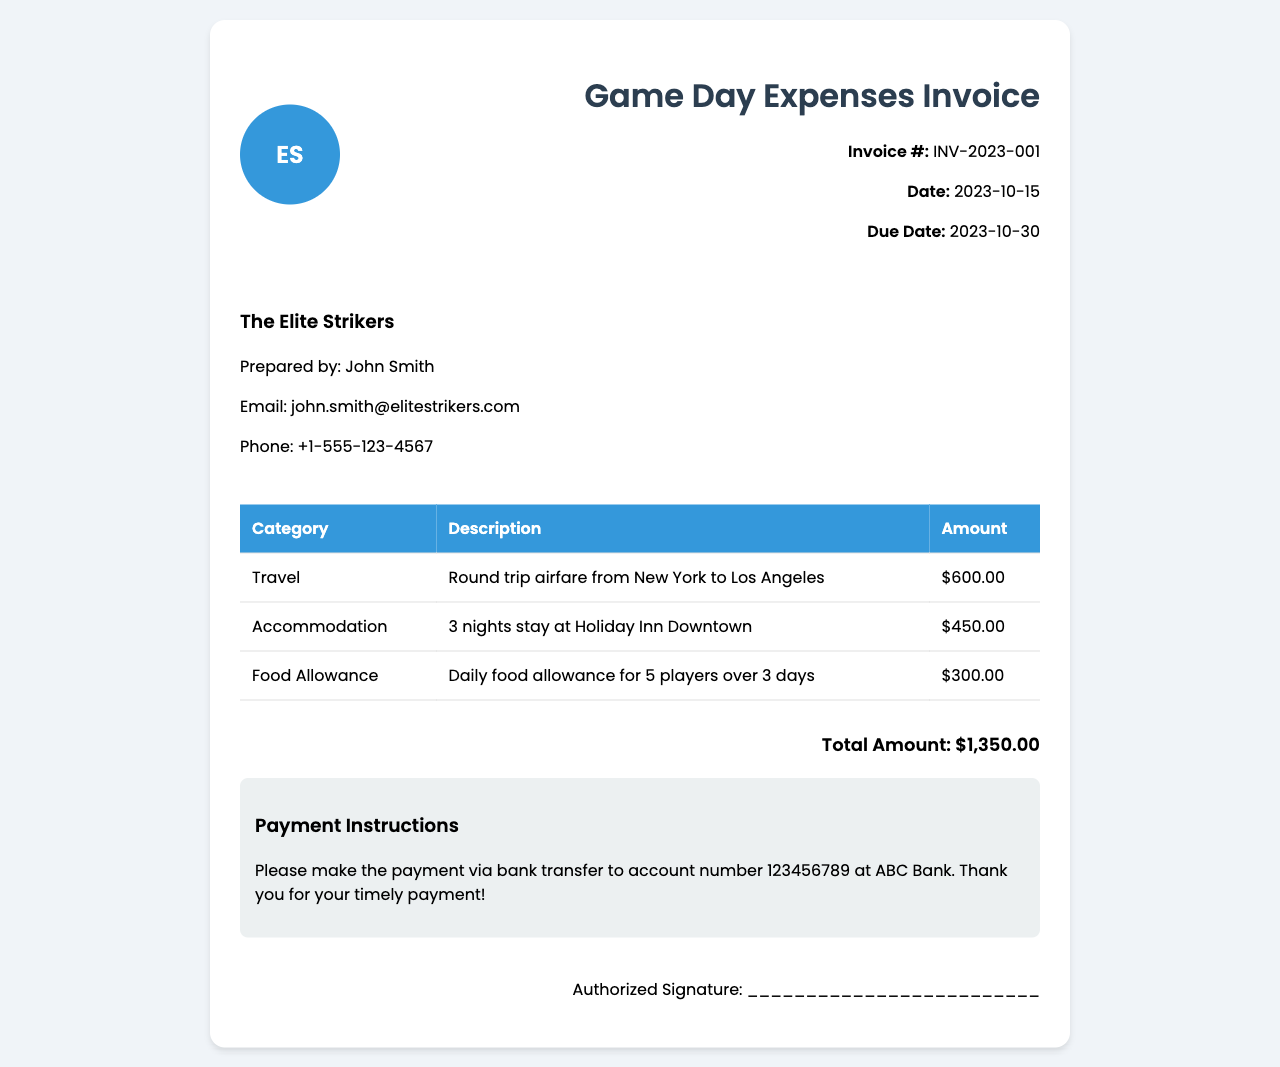What is the invoice number? The invoice number is listed in the document as a unique identifier for the invoice.
Answer: INV-2023-001 What is the date of the invoice? The date indicates when the invoice was issued, which is provided in the document.
Answer: 2023-10-15 How much was spent on accommodation? The accommodation cost is a specific line item in the invoice detailing the expenses.
Answer: $450.00 Who prepared the invoice? The preparer's name is mentioned to indicate responsibility for the document.
Answer: John Smith How many nights was the team accommodated? The number of nights is specified in the description of the accommodation expense.
Answer: 3 nights What is the total amount due? The total amount due summarizes all expenses listed in the invoice.
Answer: $1,350.00 What type of payment is requested? The payment method is described in the payment instructions section of the invoice.
Answer: Bank transfer What is the due date for payment? The due date indicates when the payment should be made as specified in the document.
Answer: 2023-10-30 What category does the $600 expense belong to? The category associated with the expense is listed next to each amount in the invoice.
Answer: Travel 